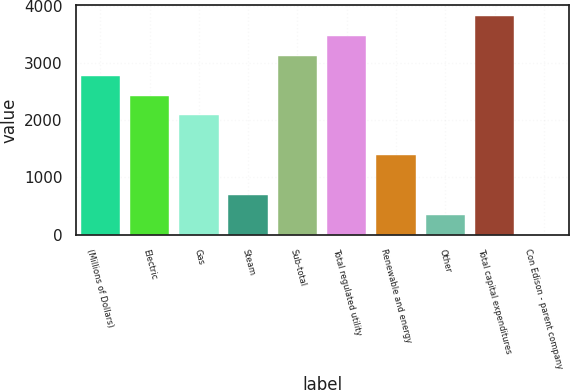<chart> <loc_0><loc_0><loc_500><loc_500><bar_chart><fcel>(Millions of Dollars)<fcel>Electric<fcel>Gas<fcel>Steam<fcel>Sub-total<fcel>Total regulated utility<fcel>Renewable and energy<fcel>Other<fcel>Total capital expenditures<fcel>Con Edison - parent company<nl><fcel>2778<fcel>2431<fcel>2084<fcel>696<fcel>3125<fcel>3472<fcel>1390<fcel>349<fcel>3819<fcel>2<nl></chart> 